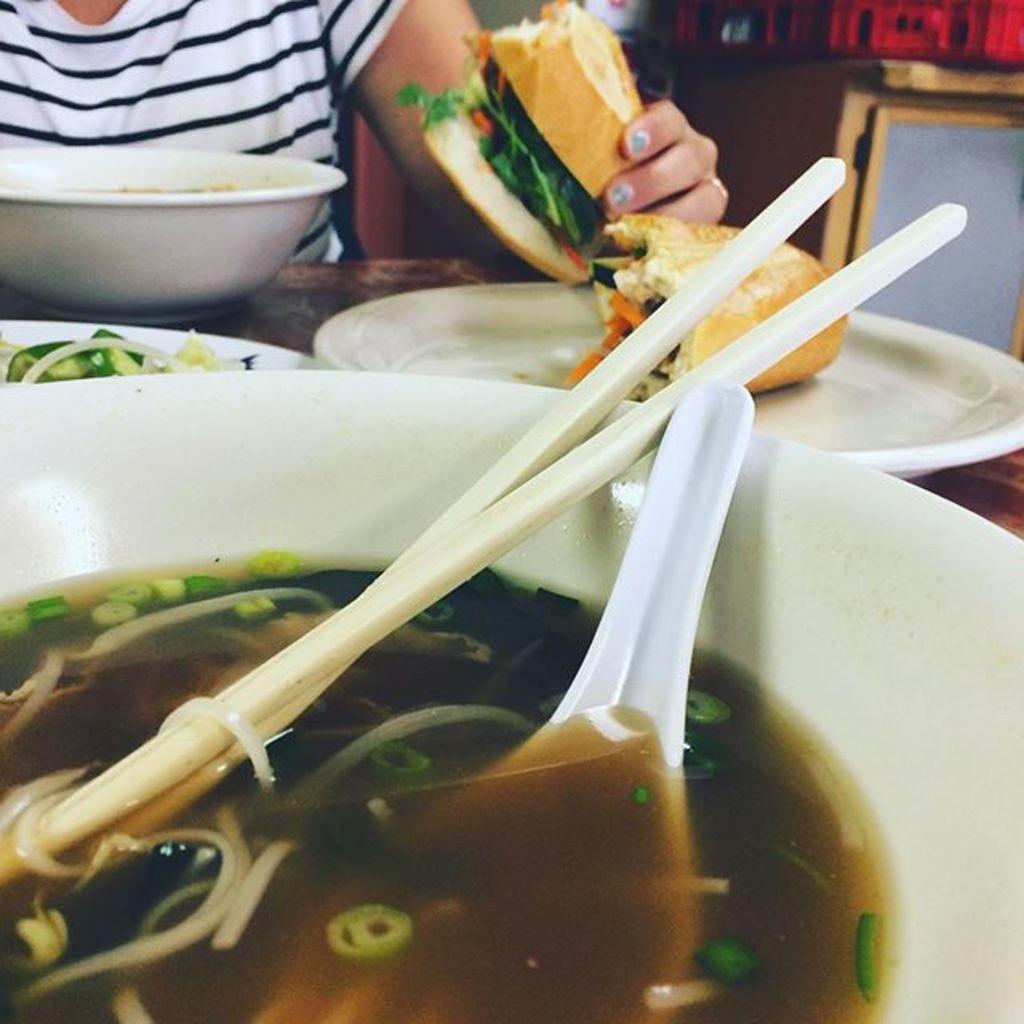Describe this image in one or two sentences. In this picture a person is holding a burger, in front the person there is a table on the table there is a bowl, plate and in the bowl there is a soup, chopsticks, and spoon. 